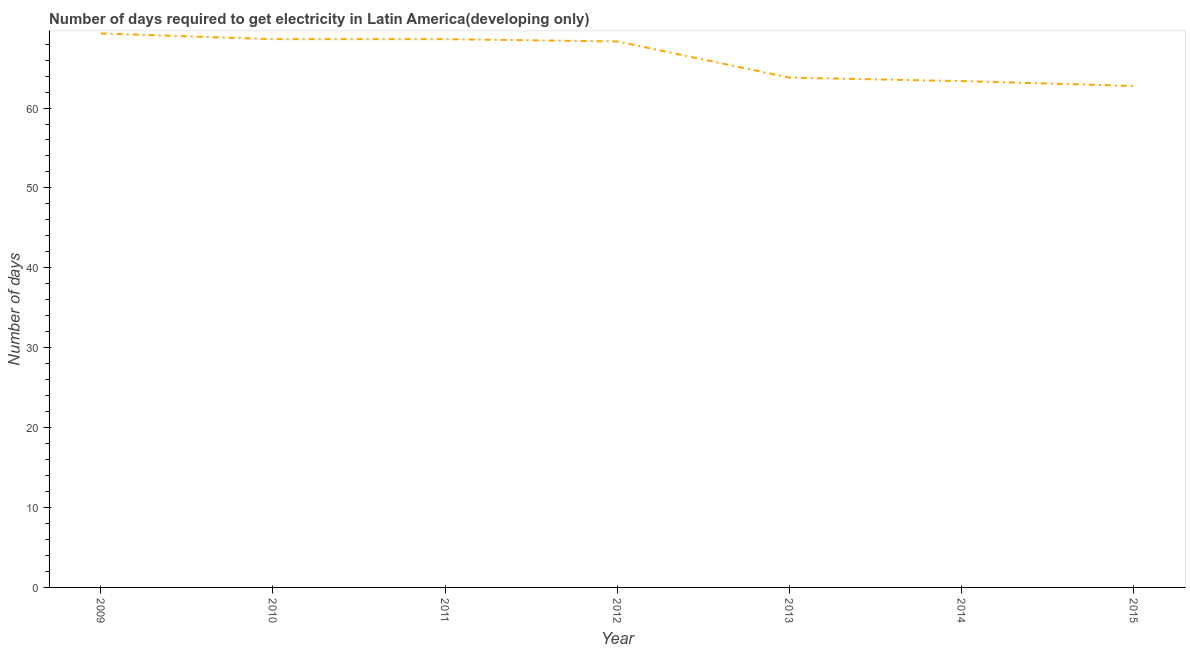What is the time to get electricity in 2012?
Keep it short and to the point. 68.33. Across all years, what is the maximum time to get electricity?
Ensure brevity in your answer.  69.33. Across all years, what is the minimum time to get electricity?
Your response must be concise. 62.76. In which year was the time to get electricity maximum?
Make the answer very short. 2009. In which year was the time to get electricity minimum?
Your response must be concise. 2015. What is the sum of the time to get electricity?
Make the answer very short. 464.84. What is the difference between the time to get electricity in 2014 and 2015?
Provide a succinct answer. 0.61. What is the average time to get electricity per year?
Give a very brief answer. 66.41. What is the median time to get electricity?
Ensure brevity in your answer.  68.33. In how many years, is the time to get electricity greater than 34 ?
Make the answer very short. 7. What is the ratio of the time to get electricity in 2011 to that in 2015?
Your answer should be very brief. 1.09. Is the time to get electricity in 2009 less than that in 2014?
Ensure brevity in your answer.  No. Is the difference between the time to get electricity in 2009 and 2010 greater than the difference between any two years?
Make the answer very short. No. What is the difference between the highest and the second highest time to get electricity?
Your answer should be compact. 0.71. Is the sum of the time to get electricity in 2009 and 2012 greater than the maximum time to get electricity across all years?
Give a very brief answer. Yes. What is the difference between the highest and the lowest time to get electricity?
Your answer should be very brief. 6.57. In how many years, is the time to get electricity greater than the average time to get electricity taken over all years?
Offer a very short reply. 4. Does the time to get electricity monotonically increase over the years?
Your answer should be compact. No. What is the difference between two consecutive major ticks on the Y-axis?
Your answer should be very brief. 10. Does the graph contain any zero values?
Keep it short and to the point. No. What is the title of the graph?
Offer a terse response. Number of days required to get electricity in Latin America(developing only). What is the label or title of the X-axis?
Give a very brief answer. Year. What is the label or title of the Y-axis?
Your answer should be very brief. Number of days. What is the Number of days in 2009?
Keep it short and to the point. 69.33. What is the Number of days in 2010?
Offer a terse response. 68.62. What is the Number of days of 2011?
Ensure brevity in your answer.  68.62. What is the Number of days of 2012?
Offer a very short reply. 68.33. What is the Number of days of 2013?
Your answer should be compact. 63.8. What is the Number of days in 2014?
Your answer should be compact. 63.37. What is the Number of days of 2015?
Your response must be concise. 62.76. What is the difference between the Number of days in 2009 and 2010?
Keep it short and to the point. 0.71. What is the difference between the Number of days in 2009 and 2011?
Offer a very short reply. 0.71. What is the difference between the Number of days in 2009 and 2013?
Your response must be concise. 5.53. What is the difference between the Number of days in 2009 and 2014?
Your response must be concise. 5.96. What is the difference between the Number of days in 2009 and 2015?
Provide a succinct answer. 6.57. What is the difference between the Number of days in 2010 and 2011?
Your answer should be very brief. 0. What is the difference between the Number of days in 2010 and 2012?
Make the answer very short. 0.29. What is the difference between the Number of days in 2010 and 2013?
Provide a short and direct response. 4.81. What is the difference between the Number of days in 2010 and 2014?
Offer a terse response. 5.25. What is the difference between the Number of days in 2010 and 2015?
Provide a short and direct response. 5.86. What is the difference between the Number of days in 2011 and 2012?
Provide a succinct answer. 0.29. What is the difference between the Number of days in 2011 and 2013?
Your answer should be compact. 4.81. What is the difference between the Number of days in 2011 and 2014?
Provide a succinct answer. 5.25. What is the difference between the Number of days in 2011 and 2015?
Offer a terse response. 5.86. What is the difference between the Number of days in 2012 and 2013?
Your answer should be compact. 4.53. What is the difference between the Number of days in 2012 and 2014?
Ensure brevity in your answer.  4.96. What is the difference between the Number of days in 2012 and 2015?
Make the answer very short. 5.57. What is the difference between the Number of days in 2013 and 2014?
Provide a succinct answer. 0.43. What is the difference between the Number of days in 2013 and 2015?
Offer a terse response. 1.04. What is the difference between the Number of days in 2014 and 2015?
Your response must be concise. 0.61. What is the ratio of the Number of days in 2009 to that in 2010?
Offer a terse response. 1.01. What is the ratio of the Number of days in 2009 to that in 2011?
Offer a terse response. 1.01. What is the ratio of the Number of days in 2009 to that in 2013?
Your answer should be very brief. 1.09. What is the ratio of the Number of days in 2009 to that in 2014?
Provide a succinct answer. 1.09. What is the ratio of the Number of days in 2009 to that in 2015?
Provide a short and direct response. 1.1. What is the ratio of the Number of days in 2010 to that in 2011?
Provide a succinct answer. 1. What is the ratio of the Number of days in 2010 to that in 2013?
Provide a short and direct response. 1.07. What is the ratio of the Number of days in 2010 to that in 2014?
Your answer should be very brief. 1.08. What is the ratio of the Number of days in 2010 to that in 2015?
Offer a terse response. 1.09. What is the ratio of the Number of days in 2011 to that in 2013?
Your answer should be very brief. 1.07. What is the ratio of the Number of days in 2011 to that in 2014?
Offer a terse response. 1.08. What is the ratio of the Number of days in 2011 to that in 2015?
Ensure brevity in your answer.  1.09. What is the ratio of the Number of days in 2012 to that in 2013?
Your response must be concise. 1.07. What is the ratio of the Number of days in 2012 to that in 2014?
Offer a very short reply. 1.08. What is the ratio of the Number of days in 2012 to that in 2015?
Ensure brevity in your answer.  1.09. What is the ratio of the Number of days in 2013 to that in 2014?
Offer a terse response. 1.01. What is the ratio of the Number of days in 2014 to that in 2015?
Your response must be concise. 1.01. 